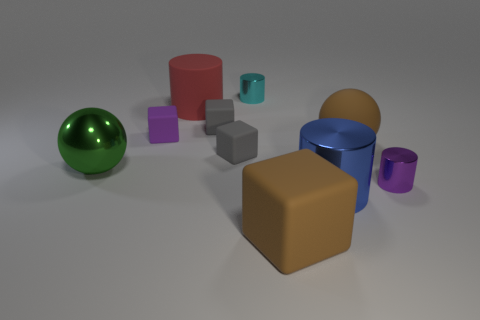Subtract all small blocks. How many blocks are left? 1 Subtract all red cylinders. How many cylinders are left? 3 Add 9 big brown rubber balls. How many big brown rubber balls are left? 10 Add 3 small green things. How many small green things exist? 3 Subtract 1 brown balls. How many objects are left? 9 Subtract all spheres. How many objects are left? 8 Subtract 2 spheres. How many spheres are left? 0 Subtract all purple cylinders. Subtract all red spheres. How many cylinders are left? 3 Subtract all brown cylinders. How many blue balls are left? 0 Subtract all large yellow matte cylinders. Subtract all tiny objects. How many objects are left? 5 